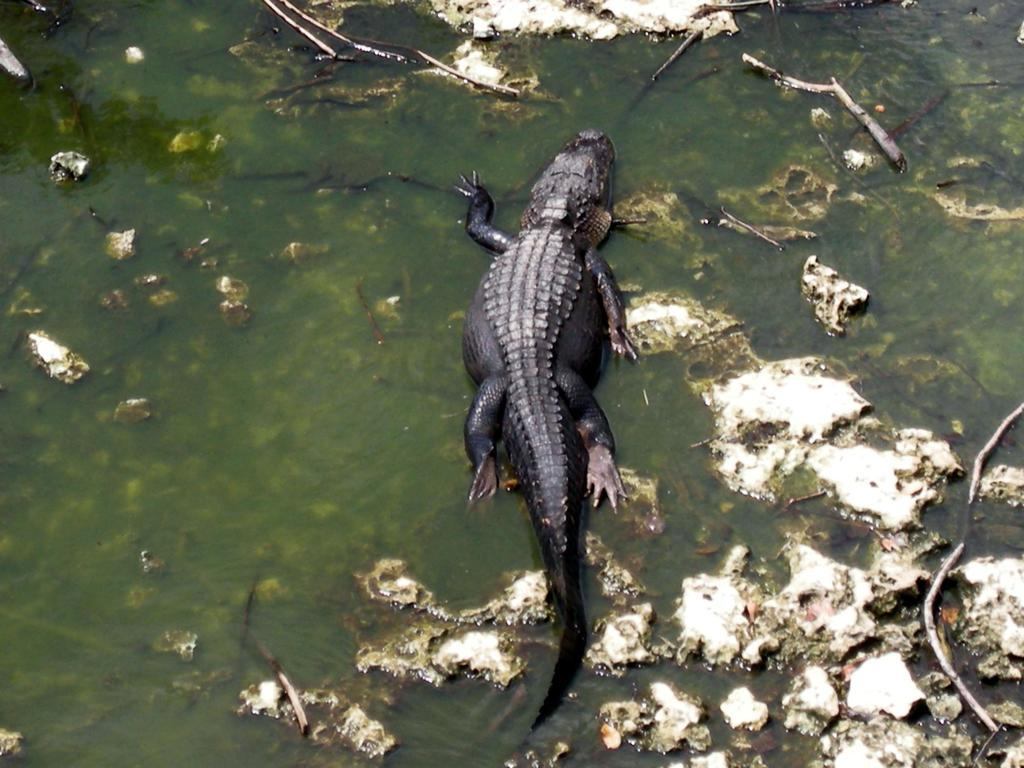Where was the image taken? The image was taken outdoors. What can be seen at the bottom of the image? There is a pond with water and stones in it at the bottom of the image. What is the main subject in the middle of the image? There is a crocodile in the middle of the image. What is the color of the crocodile? The crocodile is black in color. Can you see a boat in the image? No, there is no boat present in the image. 